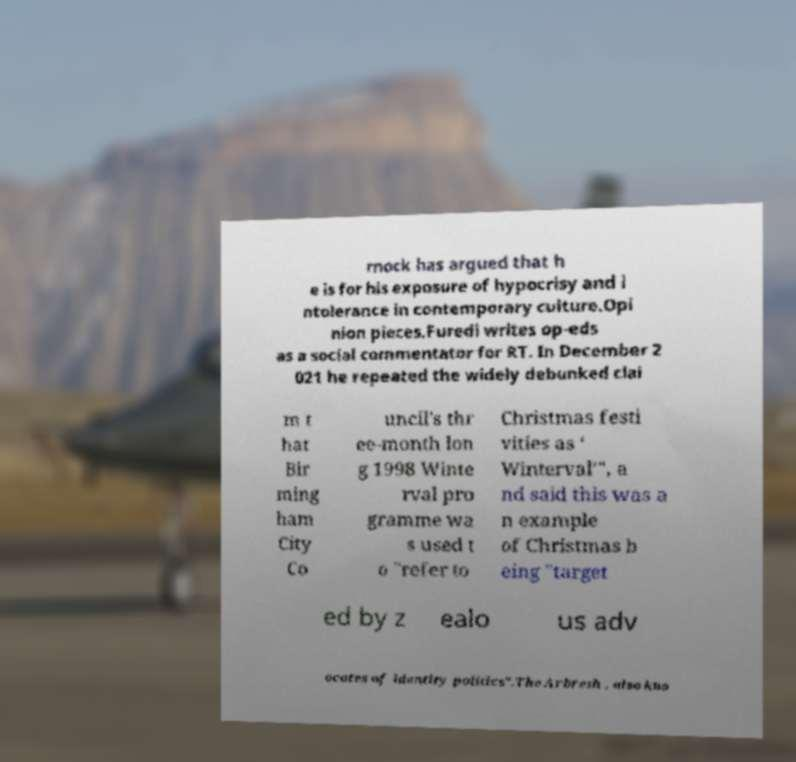Please read and relay the text visible in this image. What does it say? rnock has argued that h e is for his exposure of hypocrisy and i ntolerance in contemporary culture.Opi nion pieces.Furedi writes op-eds as a social commentator for RT. In December 2 021 he repeated the widely debunked clai m t hat Bir ming ham City Co uncil's thr ee-month lon g 1998 Winte rval pro gramme wa s used t o "refer to Christmas festi vities as ‘ Winterval’", a nd said this was a n example of Christmas b eing "target ed by z ealo us adv ocates of identity politics".The Arbresh , also kno 